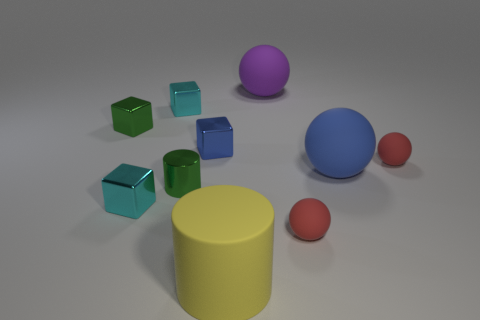Subtract all green metal blocks. How many blocks are left? 3 Subtract all gray cylinders. How many red balls are left? 2 Subtract all purple spheres. How many spheres are left? 3 Subtract 2 cubes. How many cubes are left? 2 Subtract all brown balls. Subtract all blue cylinders. How many balls are left? 4 Subtract all spheres. How many objects are left? 6 Subtract all small red matte balls. Subtract all tiny green metallic objects. How many objects are left? 6 Add 1 small red matte spheres. How many small red matte spheres are left? 3 Add 7 green rubber cylinders. How many green rubber cylinders exist? 7 Subtract 1 yellow cylinders. How many objects are left? 9 